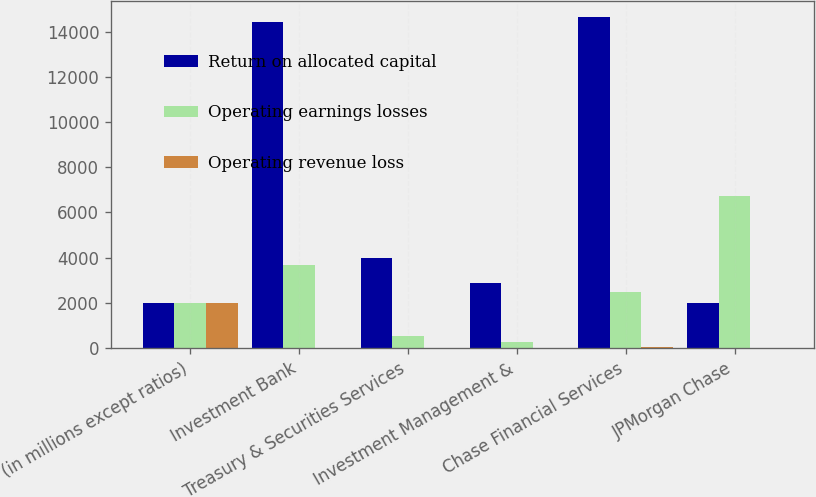<chart> <loc_0><loc_0><loc_500><loc_500><stacked_bar_chart><ecel><fcel>(in millions except ratios)<fcel>Investment Bank<fcel>Treasury & Securities Services<fcel>Investment Management &<fcel>Chase Financial Services<fcel>JPMorgan Chase<nl><fcel>Return on allocated capital<fcel>2003<fcel>14440<fcel>3992<fcel>2878<fcel>14632<fcel>2003<nl><fcel>Operating earnings losses<fcel>2003<fcel>3685<fcel>520<fcel>268<fcel>2495<fcel>6719<nl><fcel>Operating revenue loss<fcel>2003<fcel>19<fcel>19<fcel>5<fcel>28<fcel>16<nl></chart> 